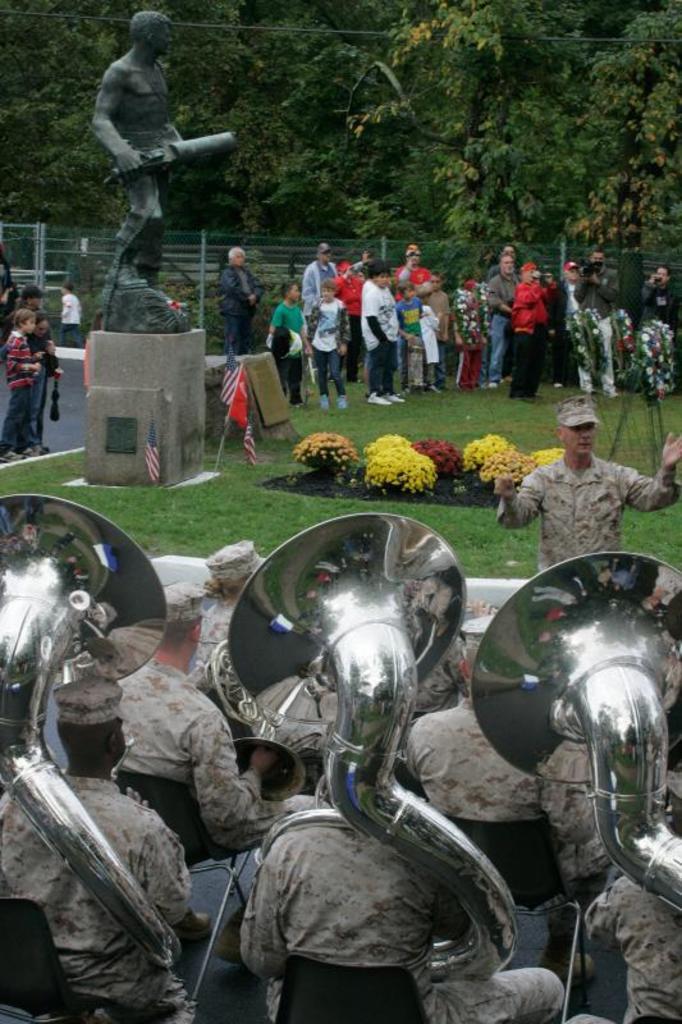Can you describe this image briefly? In the foreground of the picture there are soldiers sitting in chairs and playing brass instruments. In the center the picture there are flowers, grass, flags, people, fencing and a statue. In the background there are trees. 